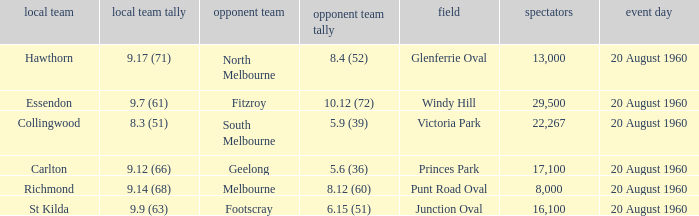What is the venue when Geelong is the away team? Princes Park. 